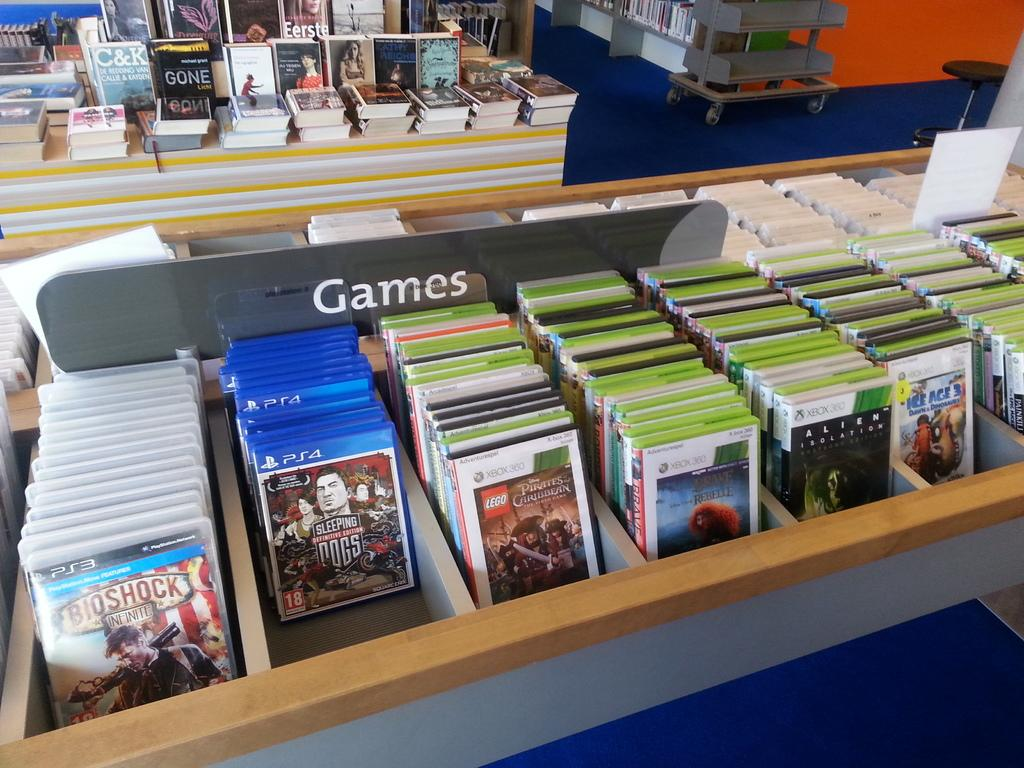Provide a one-sentence caption for the provided image. A store rack full of video games has a label sign that reads "Games". 